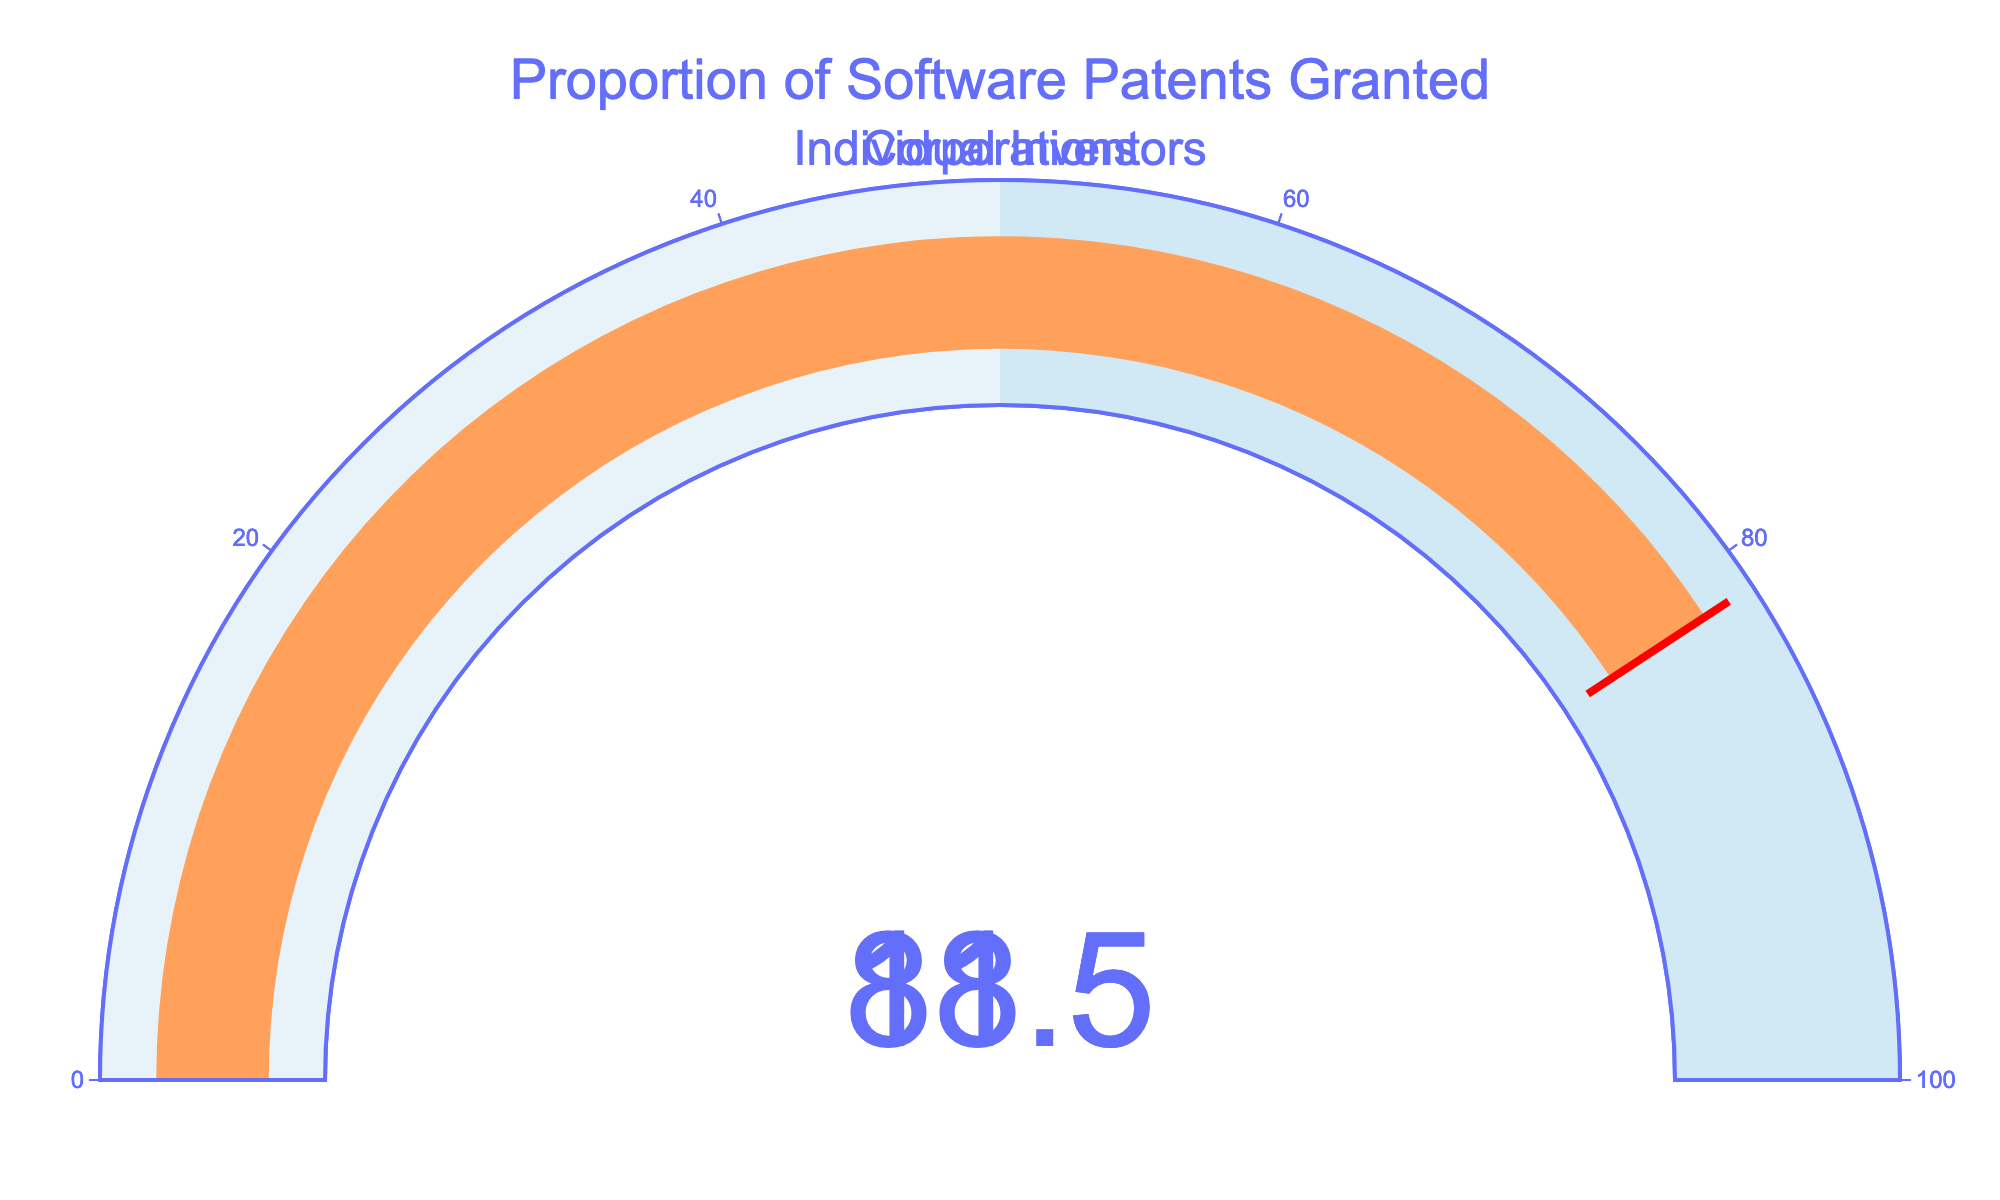What is the proportion of software patents granted to individual inventors? The gauge chart indicates this with its numeric value display. Refer to the number shown in the gauge chart labeled "Individual Inventors."
Answer: 18.5% What is the proportion of software patents granted to corporations? The gauge chart indicates this with its numeric value display. Refer to the number shown in the gauge chart labeled "Corporations."
Answer: 81.5% Which category has a higher proportion of software patents granted? Compare the numeric values displayed on the two gauges. The gauge with the higher number indicates the category with a higher proportion.
Answer: Corporations By how much is the proportion of software patents granted to corporations greater than that for individual inventors? Calculate the difference between the values of the "Corporations" and "Individual Inventors" gauges: 81.5 - 18.5.
Answer: 63% What is the combined percentage of software patents granted to both individual inventors and corporations? Add the values displayed on the two gauges: 18.5 (individual inventors) + 81.5 (corporations).
Answer: 100% Is the proportion of software patents granted to individual inventors below 20%? Check the numeric value on the gauge labeled "Individual Inventors." If it is less than 20%, the answer is yes.
Answer: Yes How does the visual appearance of the gauge for individual inventors differ from that for corporations? Observe the colors and gauge bar for each category. The gauge for individual inventors uses a different bar color (#19D3F3) compared to the gauge for corporations (#FFA15A).
Answer: Different bar colors: #19D3F3 for individual inventors and #FFA15A for corporations What is the significance of the red line in the gauges? The red line in each gauge represents the threshold value, which is the current value of the proportion within the gauge.
Answer: Threshold value What percentage of the gauges' range is covered by the step with color #D1E8F5? The gauge steps show ranges from 0 to 50 and 50 to 100. The step with color #D1E8F5 ranges from 50 to 100, thus covering 50% of the gauge's range.
Answer: 50% Is the title of the chart centered horizontally? The title appears at the top of the figure and is centered, aligning with where the x=0.5 on the layout.
Answer: Yes 